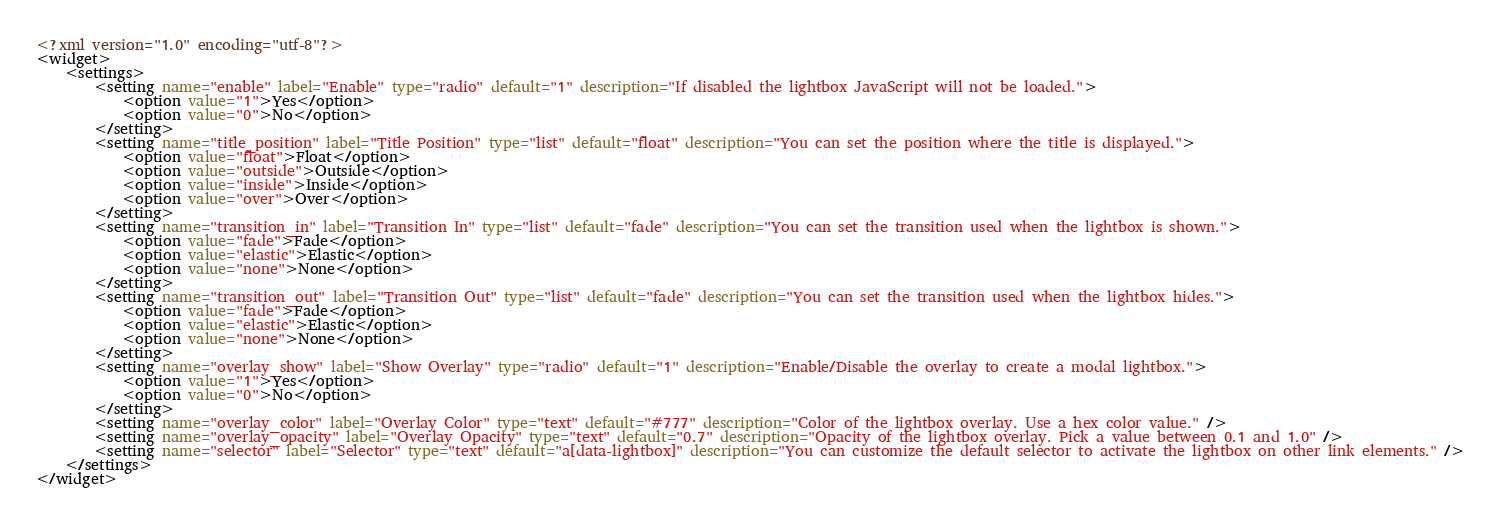<code> <loc_0><loc_0><loc_500><loc_500><_XML_><?xml version="1.0" encoding="utf-8"?>
<widget>
    <settings>
        <setting name="enable" label="Enable" type="radio" default="1" description="If disabled the lightbox JavaScript will not be loaded.">
			<option value="1">Yes</option>
			<option value="0">No</option>
		</setting>
        <setting name="title_position" label="Title Position" type="list" default="float" description="You can set the position where the title is displayed.">
			<option value="float">Float</option>
			<option value="outside">Outside</option>
			<option value="inside">Inside</option>
			<option value="over">Over</option>
		</setting>
        <setting name="transition_in" label="Transition In" type="list" default="fade" description="You can set the transition used when the lightbox is shown.">
			<option value="fade">Fade</option>
			<option value="elastic">Elastic</option>
			<option value="none">None</option>
		</setting>
        <setting name="transition_out" label="Transition Out" type="list" default="fade" description="You can set the transition used when the lightbox hides.">
			<option value="fade">Fade</option>
			<option value="elastic">Elastic</option>
			<option value="none">None</option>
		</setting>
        <setting name="overlay_show" label="Show Overlay" type="radio" default="1" description="Enable/Disable the overlay to create a modal lightbox.">
			<option value="1">Yes</option>
			<option value="0">No</option>
		</setting>
        <setting name="overlay_color" label="Overlay Color" type="text" default="#777" description="Color of the lightbox overlay. Use a hex color value." />
        <setting name="overlay_opacity" label="Overlay Opacity" type="text" default="0.7" description="Opacity of the lightbox overlay. Pick a value between 0.1 and 1.0" />
        <setting name="selector" label="Selector" type="text" default="a[data-lightbox]" description="You can customize the default selector to activate the lightbox on other link elements." />
    </settings>
</widget></code> 